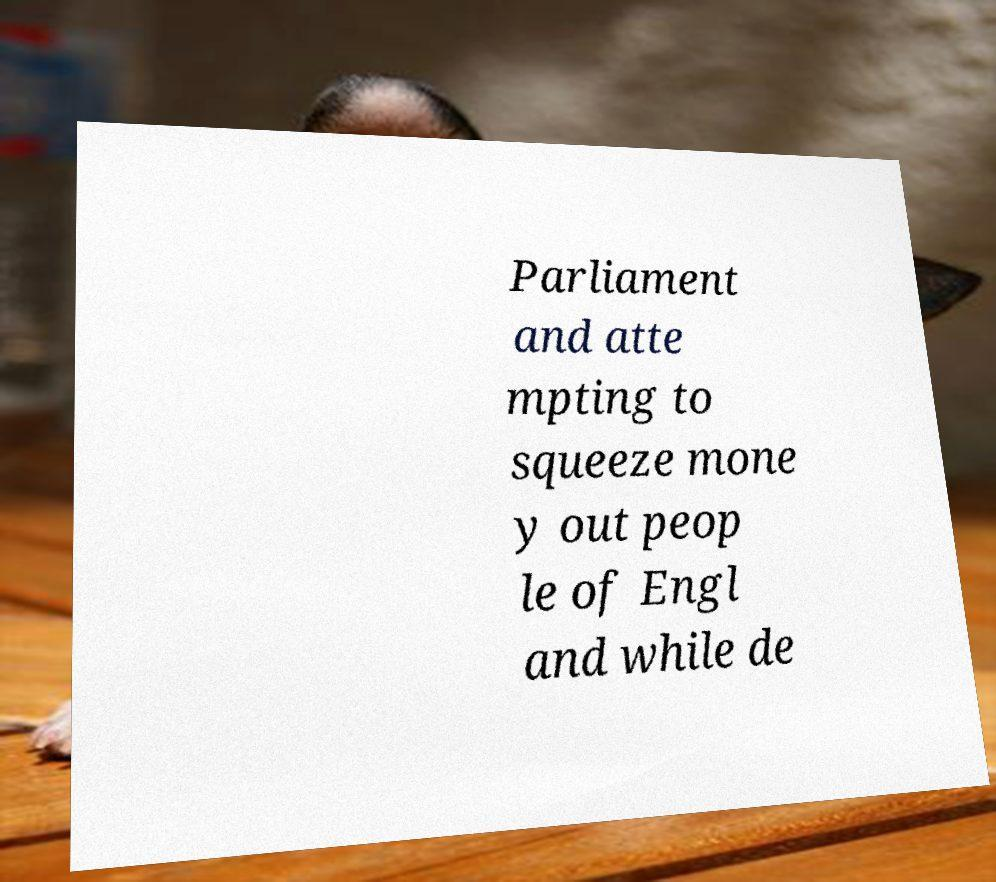Please read and relay the text visible in this image. What does it say? Parliament and atte mpting to squeeze mone y out peop le of Engl and while de 